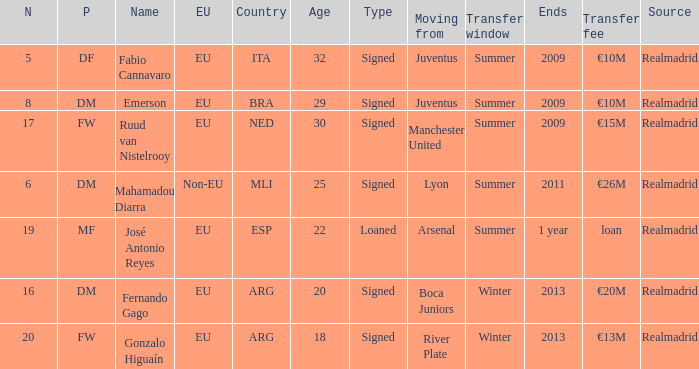What is the count of numbers that end with 1 annually? 1.0. 